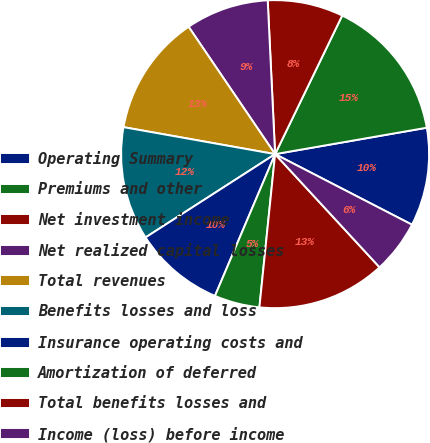Convert chart to OTSL. <chart><loc_0><loc_0><loc_500><loc_500><pie_chart><fcel>Operating Summary<fcel>Premiums and other<fcel>Net investment income<fcel>Net realized capital losses<fcel>Total revenues<fcel>Benefits losses and loss<fcel>Insurance operating costs and<fcel>Amortization of deferred<fcel>Total benefits losses and<fcel>Income (loss) before income<nl><fcel>10.32%<fcel>15.08%<fcel>7.94%<fcel>8.73%<fcel>12.7%<fcel>11.9%<fcel>9.52%<fcel>4.76%<fcel>13.49%<fcel>5.56%<nl></chart> 